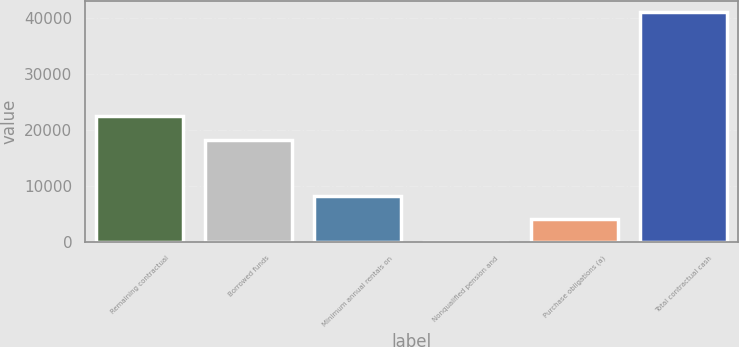Convert chart to OTSL. <chart><loc_0><loc_0><loc_500><loc_500><bar_chart><fcel>Remaining contractual<fcel>Borrowed funds<fcel>Minimum annual rentals on<fcel>Nonqualified pension and<fcel>Purchase obligations (a)<fcel>Total contractual cash<nl><fcel>22500<fcel>18309<fcel>8248.8<fcel>32<fcel>4140.4<fcel>41116<nl></chart> 